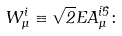<formula> <loc_0><loc_0><loc_500><loc_500>W ^ { i } _ { \mu } \equiv \sqrt { 2 } E A ^ { \bar { i } \bar { 5 } } _ { \mu } \colon</formula> 